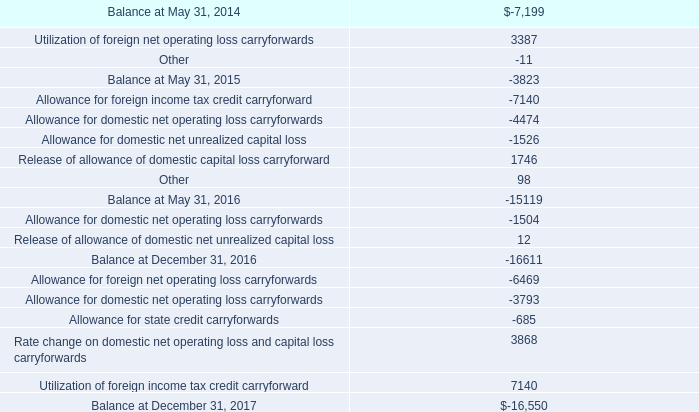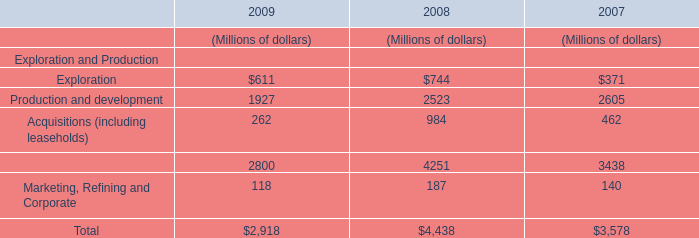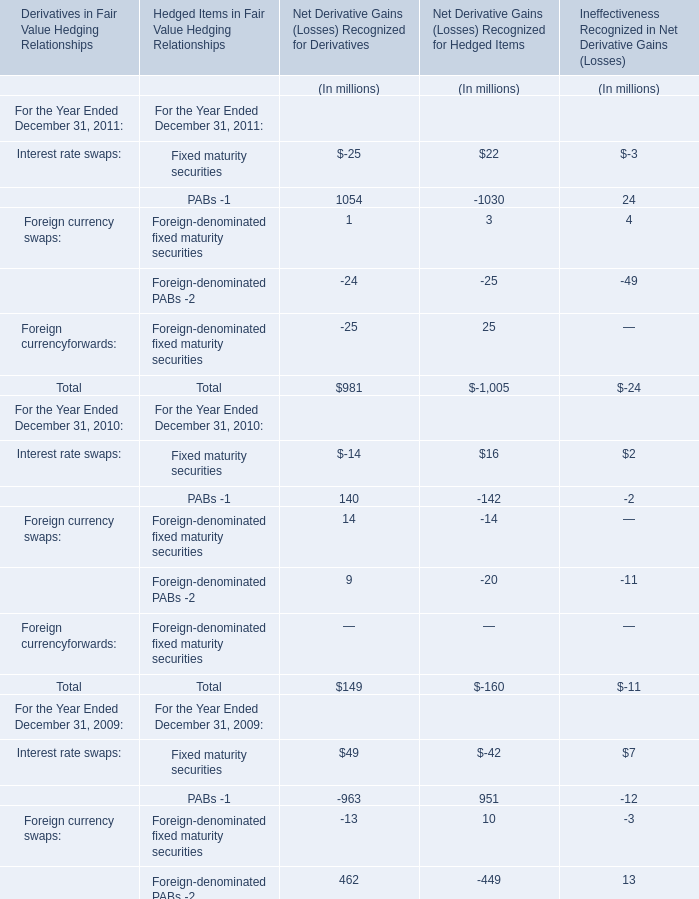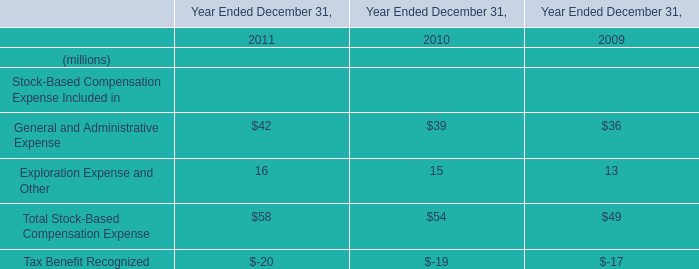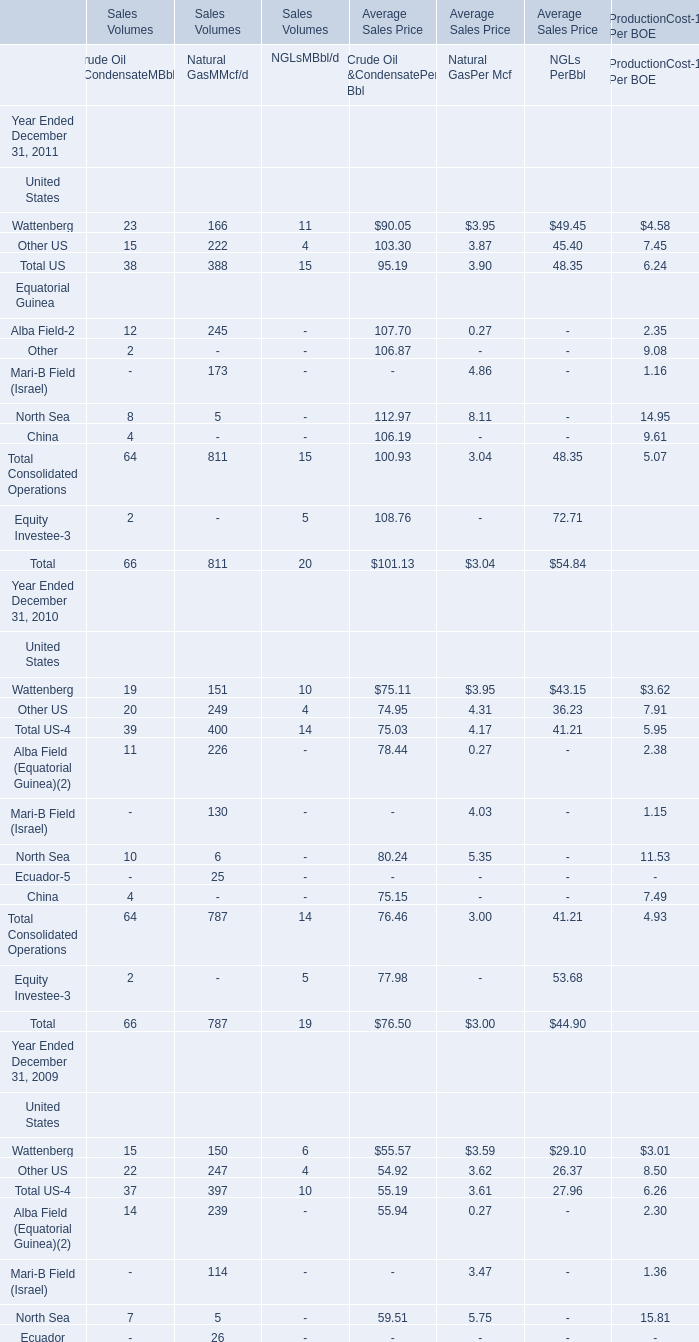What was the sum of Crude Oil &CondensateMBbl/d of Sales Volumes without those Crude Oil &CondensateMBbl/d of Sales Volumes smaller than 13 in 2011？? 
Computations: (23 + 15)
Answer: 38.0. 